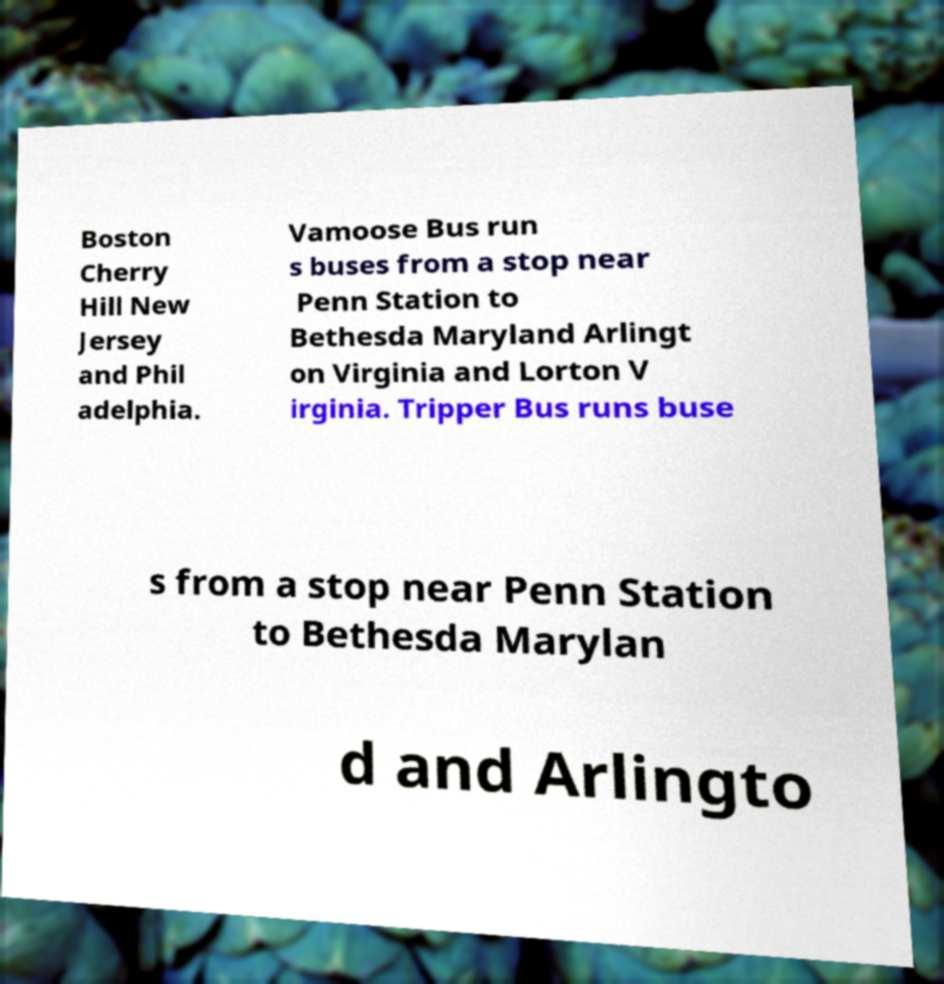Please read and relay the text visible in this image. What does it say? Boston Cherry Hill New Jersey and Phil adelphia. Vamoose Bus run s buses from a stop near Penn Station to Bethesda Maryland Arlingt on Virginia and Lorton V irginia. Tripper Bus runs buse s from a stop near Penn Station to Bethesda Marylan d and Arlingto 